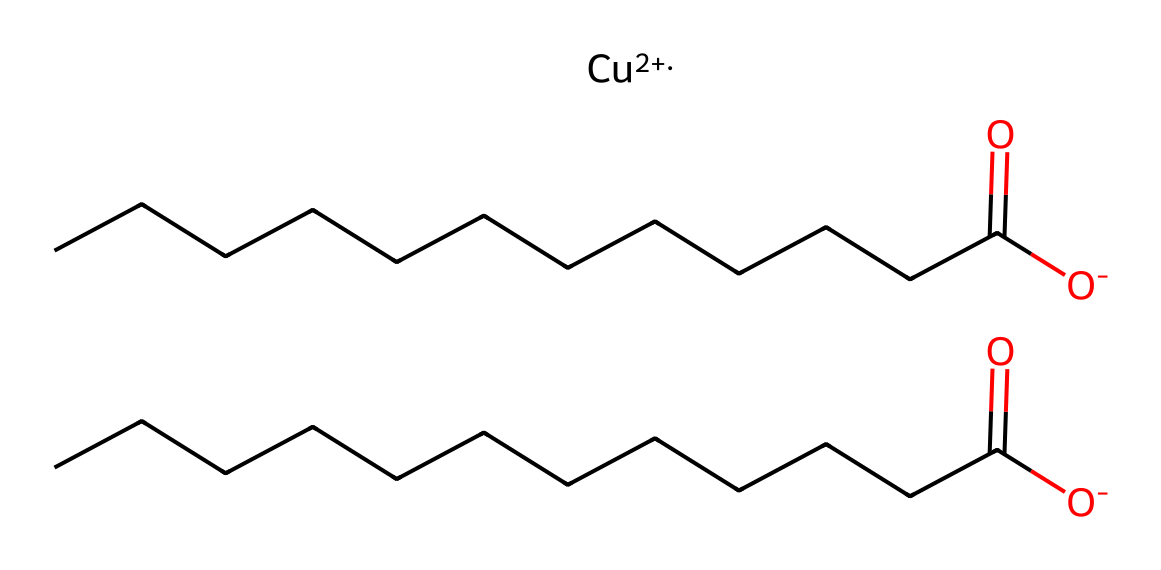What is the oxidation state of the copper in this chemical? The SMILES representation includes "[Cu+2]", indicating that the copper atom has a +2 oxidation state. The "+" sign denotes the positive charge, which signifies the oxidation state of the copper.
Answer: +2 How many carbon atoms are present in the chemical structure? The chemical structure contains segments "CCCCCCCCCCC" which indicates long carbon chains, and counting the number of 'C' in each segment gives a total of 22 carbon atoms (11 from each segment).
Answer: 22 What functional groups are present in this chemical? The chemical structure shows "C(=O)" which indicates a carbonyl group (part of a carboxylic acid), and "[O-]" which reflects the presence of a hydroxyl group when combined with carbonyl. Identifying these functional groups confirms the presence of carboxylic acids.
Answer: carboxylic acid How many oxygen atoms are there in total? From the structure, there are two carbonyl functional groups ("C(=O)") with an attached hydroxyl (which comes from "[O-]") for each group, adding up to 4 oxygen atoms combined from both segments.
Answer: 4 What type of coordination complex is indicated by the copper? The representation "[Cu+2]" suggests that the copper ion is in a coordination state with an anionic form from the oxygen of the carboxylic acids, which generally forms coordination compounds. This implies that the copper is acting as a metal center in a coordination complex.
Answer: coordination complex Are there any hydrazine groups present in this chemical? The structure does not show any "N" atoms or the specific bonding typical to hydrazine compounds. Hydrazine structures typically require a nitrogen-NH2 pattern, which is not present here, thus confirming an absence of hydrazine groups.
Answer: no 